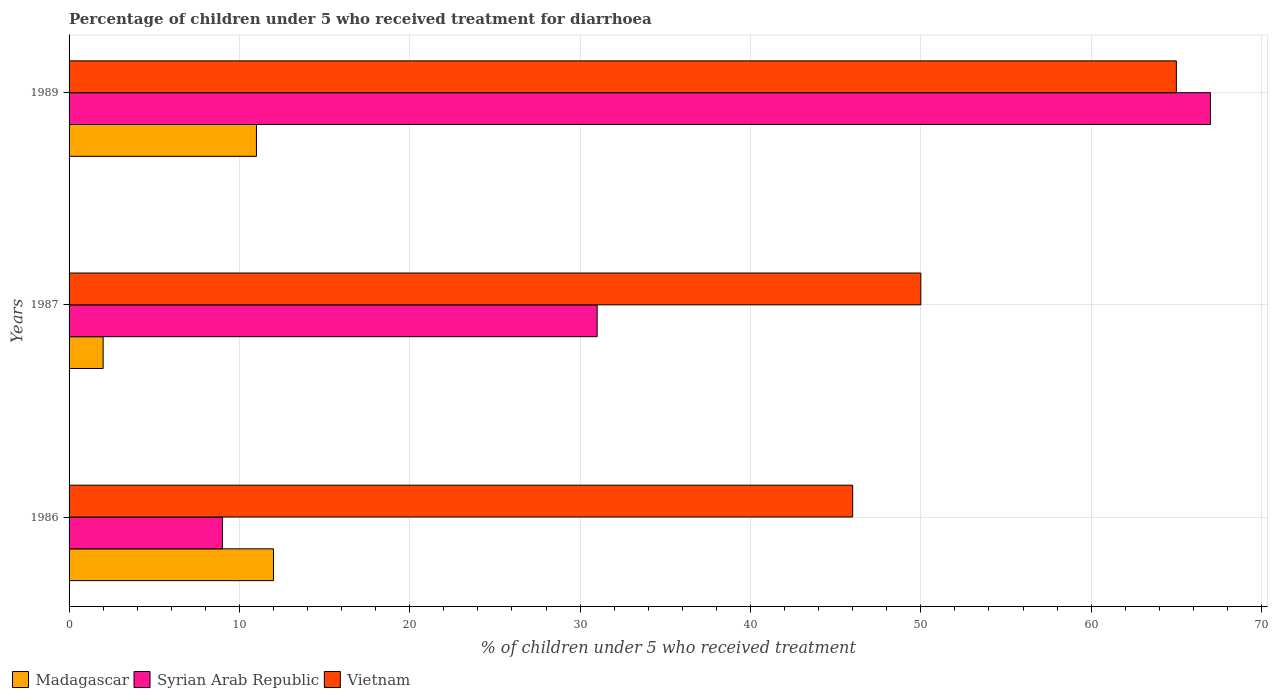How many different coloured bars are there?
Keep it short and to the point. 3. Are the number of bars per tick equal to the number of legend labels?
Your answer should be very brief. Yes. Are the number of bars on each tick of the Y-axis equal?
Offer a terse response. Yes. In how many cases, is the number of bars for a given year not equal to the number of legend labels?
Offer a very short reply. 0. Across all years, what is the minimum percentage of children who received treatment for diarrhoea  in Madagascar?
Offer a very short reply. 2. In which year was the percentage of children who received treatment for diarrhoea  in Vietnam maximum?
Your response must be concise. 1989. In which year was the percentage of children who received treatment for diarrhoea  in Vietnam minimum?
Offer a terse response. 1986. What is the total percentage of children who received treatment for diarrhoea  in Syrian Arab Republic in the graph?
Ensure brevity in your answer.  107. What is the difference between the percentage of children who received treatment for diarrhoea  in Madagascar in 1986 and that in 1987?
Provide a short and direct response. 10. What is the difference between the percentage of children who received treatment for diarrhoea  in Madagascar in 1987 and the percentage of children who received treatment for diarrhoea  in Vietnam in 1986?
Ensure brevity in your answer.  -44. What is the average percentage of children who received treatment for diarrhoea  in Madagascar per year?
Offer a terse response. 8.33. In how many years, is the percentage of children who received treatment for diarrhoea  in Vietnam greater than 2 %?
Give a very brief answer. 3. Is the percentage of children who received treatment for diarrhoea  in Vietnam in 1986 less than that in 1987?
Your response must be concise. Yes. Is the difference between the percentage of children who received treatment for diarrhoea  in Madagascar in 1986 and 1987 greater than the difference between the percentage of children who received treatment for diarrhoea  in Syrian Arab Republic in 1986 and 1987?
Your response must be concise. Yes. What is the difference between the highest and the second highest percentage of children who received treatment for diarrhoea  in Vietnam?
Provide a short and direct response. 15. What is the difference between the highest and the lowest percentage of children who received treatment for diarrhoea  in Vietnam?
Your response must be concise. 19. In how many years, is the percentage of children who received treatment for diarrhoea  in Syrian Arab Republic greater than the average percentage of children who received treatment for diarrhoea  in Syrian Arab Republic taken over all years?
Ensure brevity in your answer.  1. Is the sum of the percentage of children who received treatment for diarrhoea  in Madagascar in 1986 and 1989 greater than the maximum percentage of children who received treatment for diarrhoea  in Vietnam across all years?
Your answer should be very brief. No. What does the 2nd bar from the top in 1987 represents?
Make the answer very short. Syrian Arab Republic. What does the 2nd bar from the bottom in 1989 represents?
Your answer should be compact. Syrian Arab Republic. How many bars are there?
Ensure brevity in your answer.  9. What is the difference between two consecutive major ticks on the X-axis?
Ensure brevity in your answer.  10. Are the values on the major ticks of X-axis written in scientific E-notation?
Keep it short and to the point. No. Does the graph contain any zero values?
Give a very brief answer. No. Does the graph contain grids?
Give a very brief answer. Yes. Where does the legend appear in the graph?
Your answer should be very brief. Bottom left. How many legend labels are there?
Offer a very short reply. 3. What is the title of the graph?
Your response must be concise. Percentage of children under 5 who received treatment for diarrhoea. What is the label or title of the X-axis?
Your response must be concise. % of children under 5 who received treatment. What is the label or title of the Y-axis?
Your answer should be very brief. Years. What is the % of children under 5 who received treatment of Syrian Arab Republic in 1986?
Make the answer very short. 9. What is the % of children under 5 who received treatment of Vietnam in 1986?
Provide a short and direct response. 46. What is the % of children under 5 who received treatment of Madagascar in 1987?
Offer a terse response. 2. What is the % of children under 5 who received treatment in Madagascar in 1989?
Your response must be concise. 11. What is the % of children under 5 who received treatment of Vietnam in 1989?
Your response must be concise. 65. Across all years, what is the maximum % of children under 5 who received treatment of Madagascar?
Give a very brief answer. 12. Across all years, what is the minimum % of children under 5 who received treatment in Vietnam?
Your answer should be compact. 46. What is the total % of children under 5 who received treatment in Syrian Arab Republic in the graph?
Your answer should be very brief. 107. What is the total % of children under 5 who received treatment in Vietnam in the graph?
Offer a terse response. 161. What is the difference between the % of children under 5 who received treatment of Syrian Arab Republic in 1986 and that in 1987?
Offer a terse response. -22. What is the difference between the % of children under 5 who received treatment of Madagascar in 1986 and that in 1989?
Offer a very short reply. 1. What is the difference between the % of children under 5 who received treatment of Syrian Arab Republic in 1986 and that in 1989?
Your answer should be compact. -58. What is the difference between the % of children under 5 who received treatment in Syrian Arab Republic in 1987 and that in 1989?
Provide a short and direct response. -36. What is the difference between the % of children under 5 who received treatment in Vietnam in 1987 and that in 1989?
Provide a short and direct response. -15. What is the difference between the % of children under 5 who received treatment of Madagascar in 1986 and the % of children under 5 who received treatment of Vietnam in 1987?
Your answer should be very brief. -38. What is the difference between the % of children under 5 who received treatment in Syrian Arab Republic in 1986 and the % of children under 5 who received treatment in Vietnam in 1987?
Your response must be concise. -41. What is the difference between the % of children under 5 who received treatment of Madagascar in 1986 and the % of children under 5 who received treatment of Syrian Arab Republic in 1989?
Provide a short and direct response. -55. What is the difference between the % of children under 5 who received treatment in Madagascar in 1986 and the % of children under 5 who received treatment in Vietnam in 1989?
Provide a short and direct response. -53. What is the difference between the % of children under 5 who received treatment in Syrian Arab Republic in 1986 and the % of children under 5 who received treatment in Vietnam in 1989?
Provide a short and direct response. -56. What is the difference between the % of children under 5 who received treatment of Madagascar in 1987 and the % of children under 5 who received treatment of Syrian Arab Republic in 1989?
Your answer should be very brief. -65. What is the difference between the % of children under 5 who received treatment of Madagascar in 1987 and the % of children under 5 who received treatment of Vietnam in 1989?
Give a very brief answer. -63. What is the difference between the % of children under 5 who received treatment in Syrian Arab Republic in 1987 and the % of children under 5 who received treatment in Vietnam in 1989?
Your answer should be very brief. -34. What is the average % of children under 5 who received treatment of Madagascar per year?
Give a very brief answer. 8.33. What is the average % of children under 5 who received treatment in Syrian Arab Republic per year?
Keep it short and to the point. 35.67. What is the average % of children under 5 who received treatment of Vietnam per year?
Ensure brevity in your answer.  53.67. In the year 1986, what is the difference between the % of children under 5 who received treatment in Madagascar and % of children under 5 who received treatment in Syrian Arab Republic?
Your answer should be compact. 3. In the year 1986, what is the difference between the % of children under 5 who received treatment in Madagascar and % of children under 5 who received treatment in Vietnam?
Give a very brief answer. -34. In the year 1986, what is the difference between the % of children under 5 who received treatment in Syrian Arab Republic and % of children under 5 who received treatment in Vietnam?
Keep it short and to the point. -37. In the year 1987, what is the difference between the % of children under 5 who received treatment of Madagascar and % of children under 5 who received treatment of Syrian Arab Republic?
Ensure brevity in your answer.  -29. In the year 1987, what is the difference between the % of children under 5 who received treatment of Madagascar and % of children under 5 who received treatment of Vietnam?
Provide a short and direct response. -48. In the year 1987, what is the difference between the % of children under 5 who received treatment of Syrian Arab Republic and % of children under 5 who received treatment of Vietnam?
Ensure brevity in your answer.  -19. In the year 1989, what is the difference between the % of children under 5 who received treatment in Madagascar and % of children under 5 who received treatment in Syrian Arab Republic?
Your answer should be very brief. -56. In the year 1989, what is the difference between the % of children under 5 who received treatment of Madagascar and % of children under 5 who received treatment of Vietnam?
Ensure brevity in your answer.  -54. In the year 1989, what is the difference between the % of children under 5 who received treatment of Syrian Arab Republic and % of children under 5 who received treatment of Vietnam?
Keep it short and to the point. 2. What is the ratio of the % of children under 5 who received treatment in Madagascar in 1986 to that in 1987?
Keep it short and to the point. 6. What is the ratio of the % of children under 5 who received treatment of Syrian Arab Republic in 1986 to that in 1987?
Give a very brief answer. 0.29. What is the ratio of the % of children under 5 who received treatment in Syrian Arab Republic in 1986 to that in 1989?
Your answer should be very brief. 0.13. What is the ratio of the % of children under 5 who received treatment of Vietnam in 1986 to that in 1989?
Provide a succinct answer. 0.71. What is the ratio of the % of children under 5 who received treatment of Madagascar in 1987 to that in 1989?
Make the answer very short. 0.18. What is the ratio of the % of children under 5 who received treatment of Syrian Arab Republic in 1987 to that in 1989?
Offer a terse response. 0.46. What is the ratio of the % of children under 5 who received treatment in Vietnam in 1987 to that in 1989?
Your response must be concise. 0.77. What is the difference between the highest and the second highest % of children under 5 who received treatment in Madagascar?
Keep it short and to the point. 1. What is the difference between the highest and the second highest % of children under 5 who received treatment in Syrian Arab Republic?
Offer a terse response. 36. What is the difference between the highest and the lowest % of children under 5 who received treatment of Madagascar?
Ensure brevity in your answer.  10. What is the difference between the highest and the lowest % of children under 5 who received treatment of Syrian Arab Republic?
Your answer should be very brief. 58. 